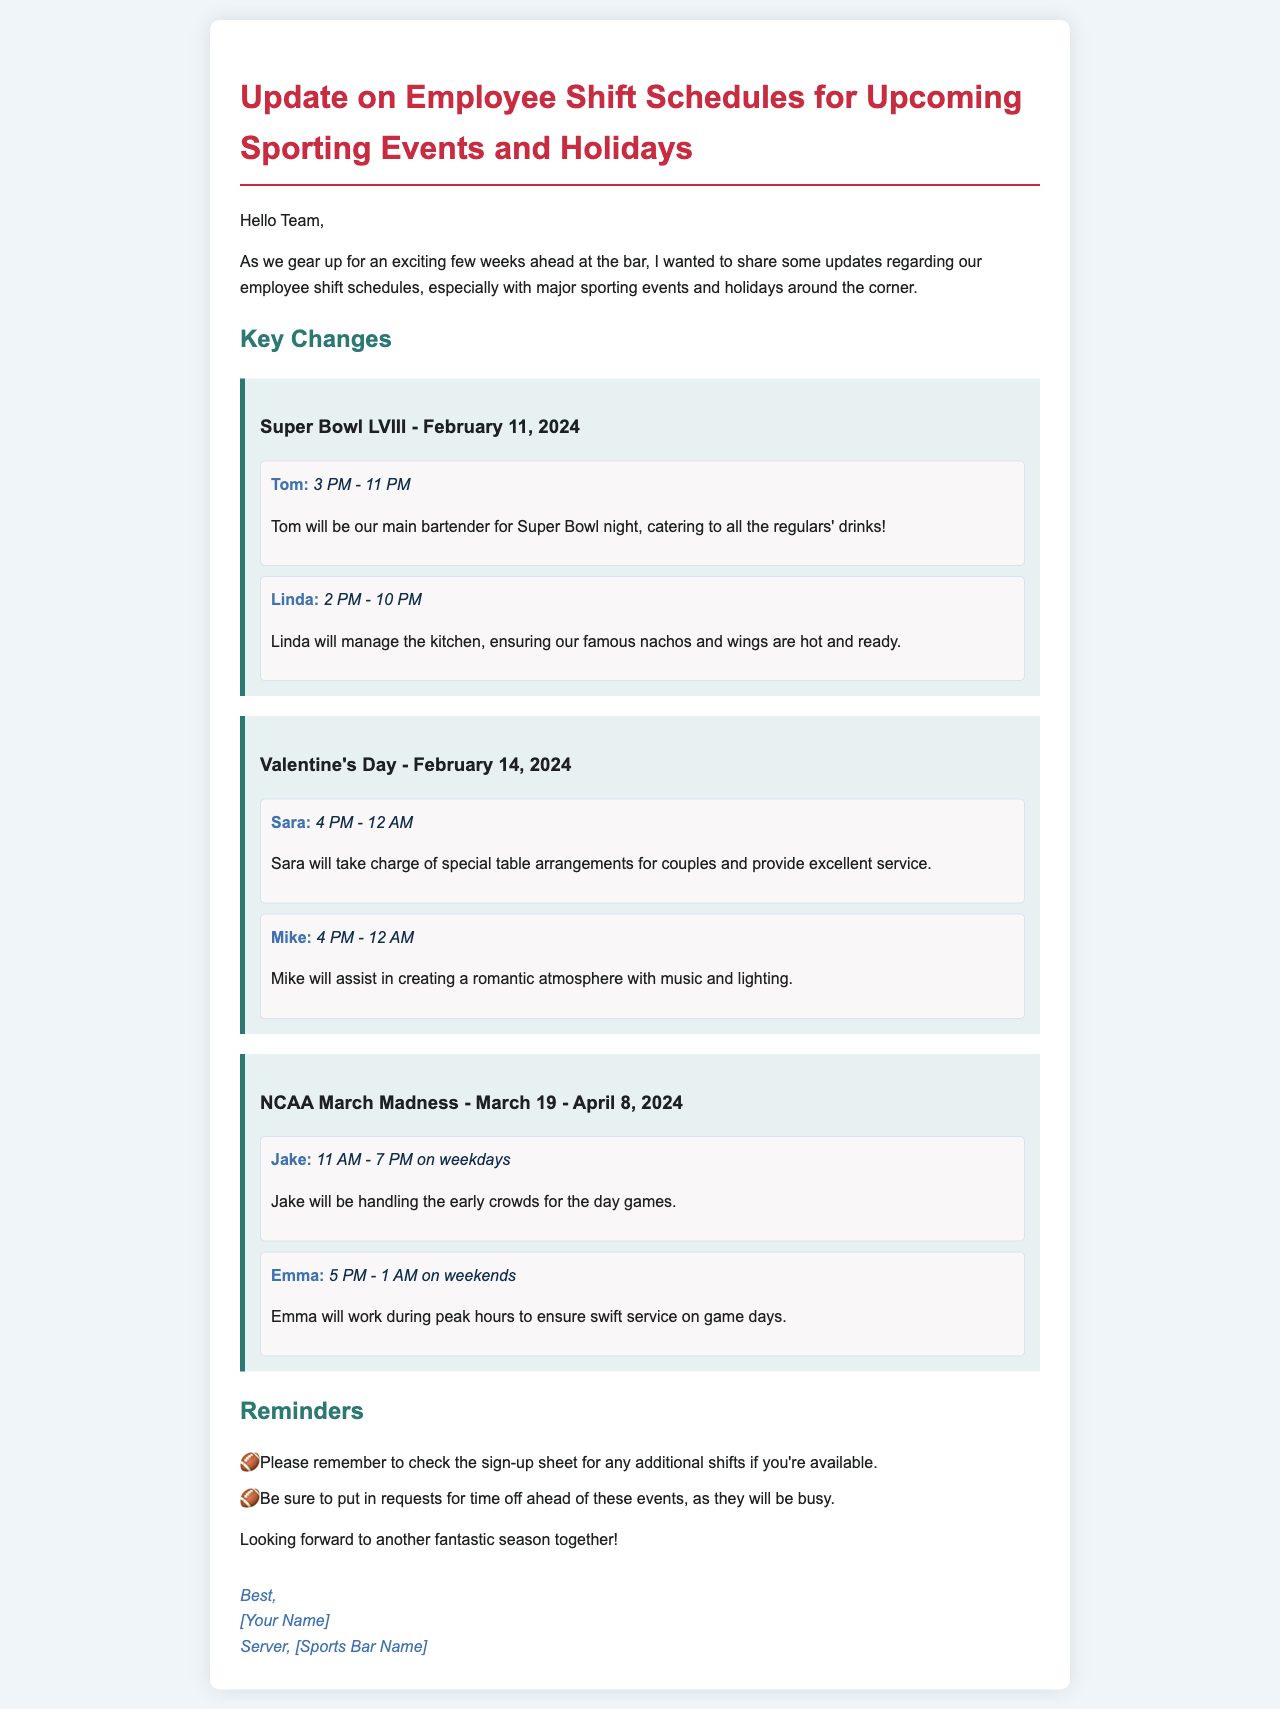What event is mentioned on February 11, 2024? The event mentioned is Super Bowl LVIII.
Answer: Super Bowl LVIII Who is the main bartender for Super Bowl night? Tom is designated as the main bartender for Super Bowl night.
Answer: Tom What is Sara's shift time on Valentine's Day? Sara's shift time on Valentine's Day is from 4 PM to 12 AM.
Answer: 4 PM - 12 AM Who will handle the early crowds during NCAA March Madness? Jake will be responsible for handling the early crowds during NCAA March Madness.
Answer: Jake What should employees do ahead of the major events? Employees should put in requests for time off ahead of these events.
Answer: Put in requests for time off 